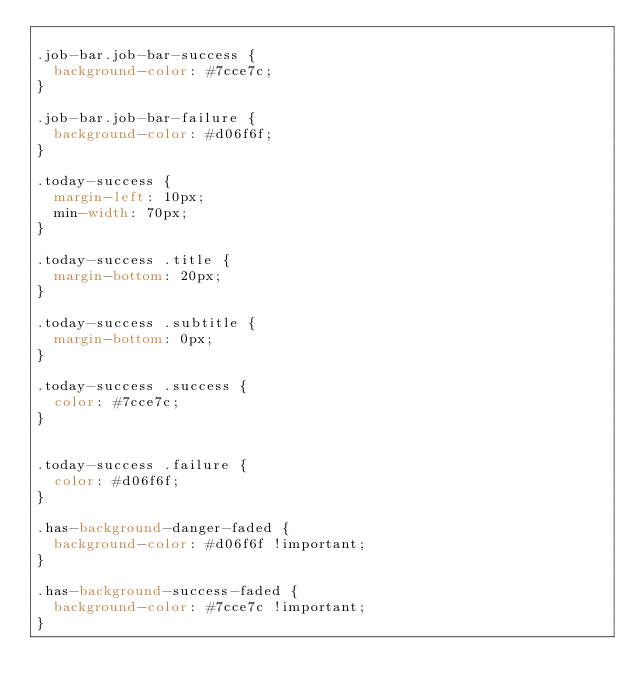Convert code to text. <code><loc_0><loc_0><loc_500><loc_500><_CSS_>
.job-bar.job-bar-success {
  background-color: #7cce7c;
}

.job-bar.job-bar-failure {
  background-color: #d06f6f;
}

.today-success {
  margin-left: 10px;
  min-width: 70px;
}

.today-success .title {
  margin-bottom: 20px;
}

.today-success .subtitle {
  margin-bottom: 0px;
}

.today-success .success {
  color: #7cce7c;
}


.today-success .failure {
  color: #d06f6f;
}

.has-background-danger-faded {
  background-color: #d06f6f !important;
}

.has-background-success-faded {
  background-color: #7cce7c !important;
}
</code> 